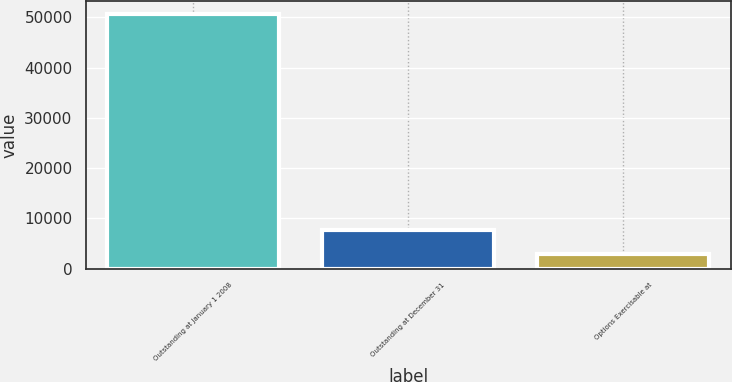Convert chart. <chart><loc_0><loc_0><loc_500><loc_500><bar_chart><fcel>Outstanding at January 1 2008<fcel>Outstanding at December 31<fcel>Options Exercisable at<nl><fcel>50692<fcel>7643.2<fcel>2860<nl></chart> 